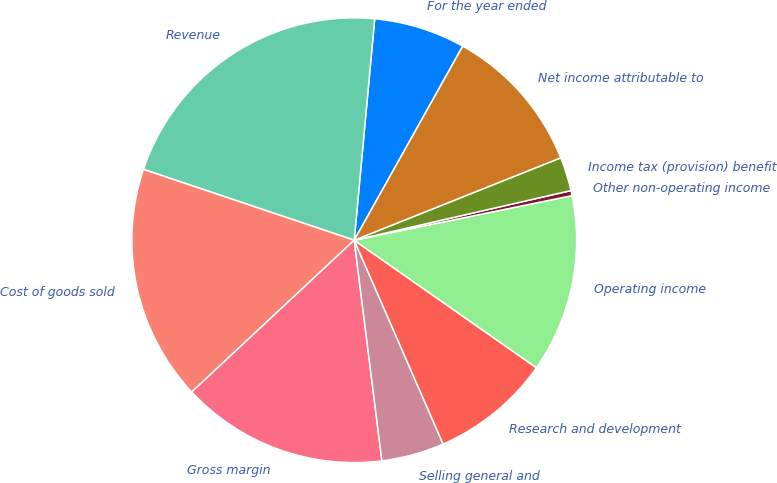<chart> <loc_0><loc_0><loc_500><loc_500><pie_chart><fcel>For the year ended<fcel>Revenue<fcel>Cost of goods sold<fcel>Gross margin<fcel>Selling general and<fcel>Research and development<fcel>Operating income<fcel>Other non-operating income<fcel>Income tax (provision) benefit<fcel>Net income attributable to<nl><fcel>6.65%<fcel>21.31%<fcel>17.12%<fcel>15.03%<fcel>4.56%<fcel>8.74%<fcel>12.93%<fcel>0.37%<fcel>2.46%<fcel>10.84%<nl></chart> 